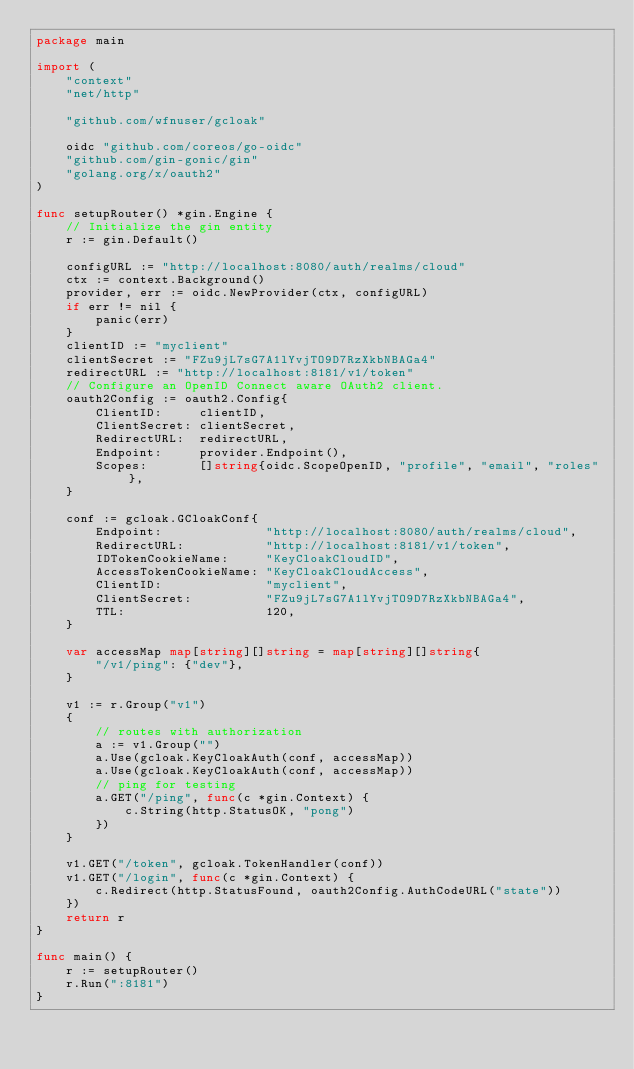Convert code to text. <code><loc_0><loc_0><loc_500><loc_500><_Go_>package main

import (
	"context"
	"net/http"

	"github.com/wfnuser/gcloak"

	oidc "github.com/coreos/go-oidc"
	"github.com/gin-gonic/gin"
	"golang.org/x/oauth2"
)

func setupRouter() *gin.Engine {
	// Initialize the gin entity
	r := gin.Default()

	configURL := "http://localhost:8080/auth/realms/cloud"
	ctx := context.Background()
	provider, err := oidc.NewProvider(ctx, configURL)
	if err != nil {
		panic(err)
	}
	clientID := "myclient"
	clientSecret := "FZu9jL7sG7A1lYvjTO9D7RzXkbNBAGa4"
	redirectURL := "http://localhost:8181/v1/token"
	// Configure an OpenID Connect aware OAuth2 client.
	oauth2Config := oauth2.Config{
		ClientID:     clientID,
		ClientSecret: clientSecret,
		RedirectURL:  redirectURL,
		Endpoint:     provider.Endpoint(),
		Scopes:       []string{oidc.ScopeOpenID, "profile", "email", "roles"},
	}

	conf := gcloak.GCloakConf{
		Endpoint:              "http://localhost:8080/auth/realms/cloud",
		RedirectURL:           "http://localhost:8181/v1/token",
		IDTokenCookieName:     "KeyCloakCloudID",
		AccessTokenCookieName: "KeyCloakCloudAccess",
		ClientID:              "myclient",
		ClientSecret:          "FZu9jL7sG7A1lYvjTO9D7RzXkbNBAGa4",
		TTL:                   120,
	}

	var accessMap map[string][]string = map[string][]string{
		"/v1/ping": {"dev"},
	}

	v1 := r.Group("v1")
	{
		// routes with authorization
		a := v1.Group("")
		a.Use(gcloak.KeyCloakAuth(conf, accessMap))
		a.Use(gcloak.KeyCloakAuth(conf, accessMap))
		// ping for testing
		a.GET("/ping", func(c *gin.Context) {
			c.String(http.StatusOK, "pong")
		})
	}

	v1.GET("/token", gcloak.TokenHandler(conf))
	v1.GET("/login", func(c *gin.Context) {
		c.Redirect(http.StatusFound, oauth2Config.AuthCodeURL("state"))
	})
	return r
}

func main() {
	r := setupRouter()
	r.Run(":8181")
}
</code> 